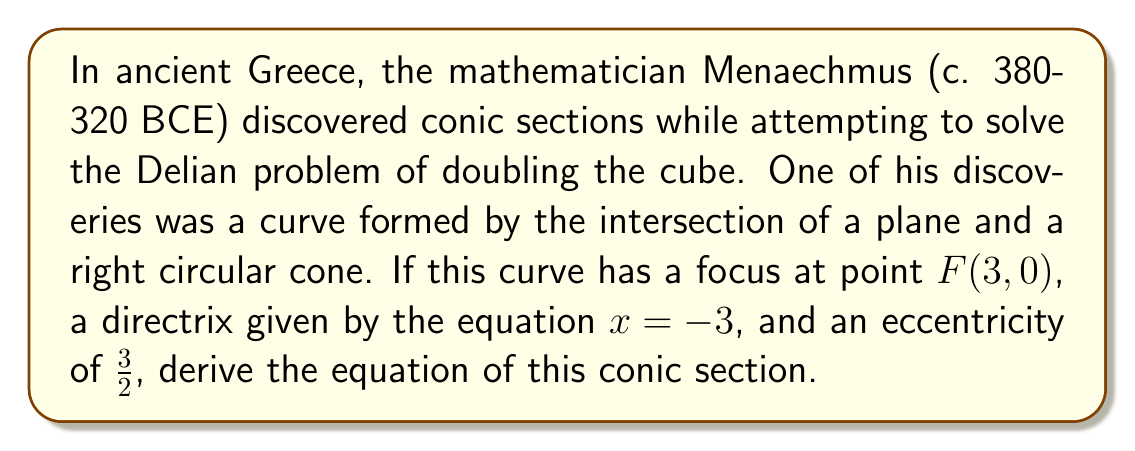Can you answer this question? Let's approach this step-by-step, drawing from the historical context of Menaechmus' work:

1) First, recall that Menaechmus discovered parabolas and hyperbolas in his quest to solve the Delian problem. The curve we're dealing with here, given its properties, is actually a hyperbola.

2) The general equation for a conic section with a focus on the x-axis and the directrix parallel to the y-axis is:

   $$(x-h)^2 = \frac{1}{1-e^2}(a^2-y^2)$$

   where $(h,0)$ is the center of the hyperbola, $e$ is the eccentricity, and $a$ is the distance from the center to the vertex.

3) We're given that the focus is at $(3,0)$ and the directrix is $x=-3$. The center of the hyperbola is halfway between these, so $h=0$.

4) The eccentricity $e = \frac{3}{2}$.

5) The distance from the center to the focus is $c=3$. We can use the relation $c = ae$ to find $a$:

   $$3 = a\cdot\frac{3}{2}$$
   $$a = 2$$

6) Now we can substitute these values into our general equation:

   $$x^2 = \frac{1}{1-(\frac{3}{2})^2}(2^2-y^2)$$

7) Simplify the fraction:

   $$x^2 = \frac{1}{1-\frac{9}{4}} = \frac{4}{-5} = -\frac{4}{5}$$

8) Substituting this back:

   $$x^2 = -\frac{4}{5}(4-y^2)$$

9) Distribute the negative:

   $$x^2 = -\frac{16}{5}+\frac{4}{5}y^2$$

10) Multiply both sides by 5:

    $$5x^2 = -16+4y^2$$

11) Rearrange to standard form:

    $$5x^2-4y^2 = 16$$

This is the equation of the hyperbola discovered by Menaechmus, represented in its standard form.
Answer: $$5x^2-4y^2 = 16$$ 